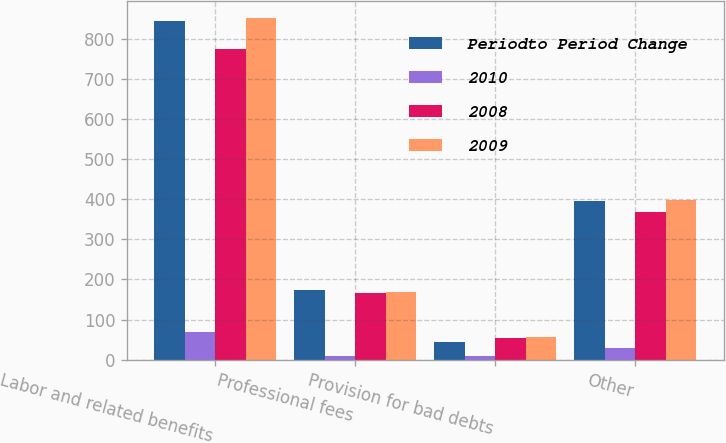<chart> <loc_0><loc_0><loc_500><loc_500><stacked_bar_chart><ecel><fcel>Labor and related benefits<fcel>Professional fees<fcel>Provision for bad debts<fcel>Other<nl><fcel>Periodto Period Change<fcel>845<fcel>175<fcel>45<fcel>396<nl><fcel>2010<fcel>70<fcel>8<fcel>9<fcel>28<nl><fcel>2008<fcel>775<fcel>167<fcel>54<fcel>368<nl><fcel>2009<fcel>853<fcel>168<fcel>57<fcel>399<nl></chart> 